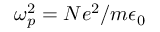Convert formula to latex. <formula><loc_0><loc_0><loc_500><loc_500>\omega _ { p } ^ { 2 } = N e ^ { 2 } / m \epsilon _ { 0 }</formula> 